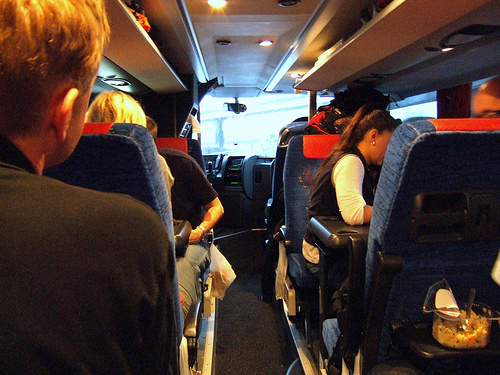<image>
Can you confirm if the man is on the seat? No. The man is not positioned on the seat. They may be near each other, but the man is not supported by or resting on top of the seat. 